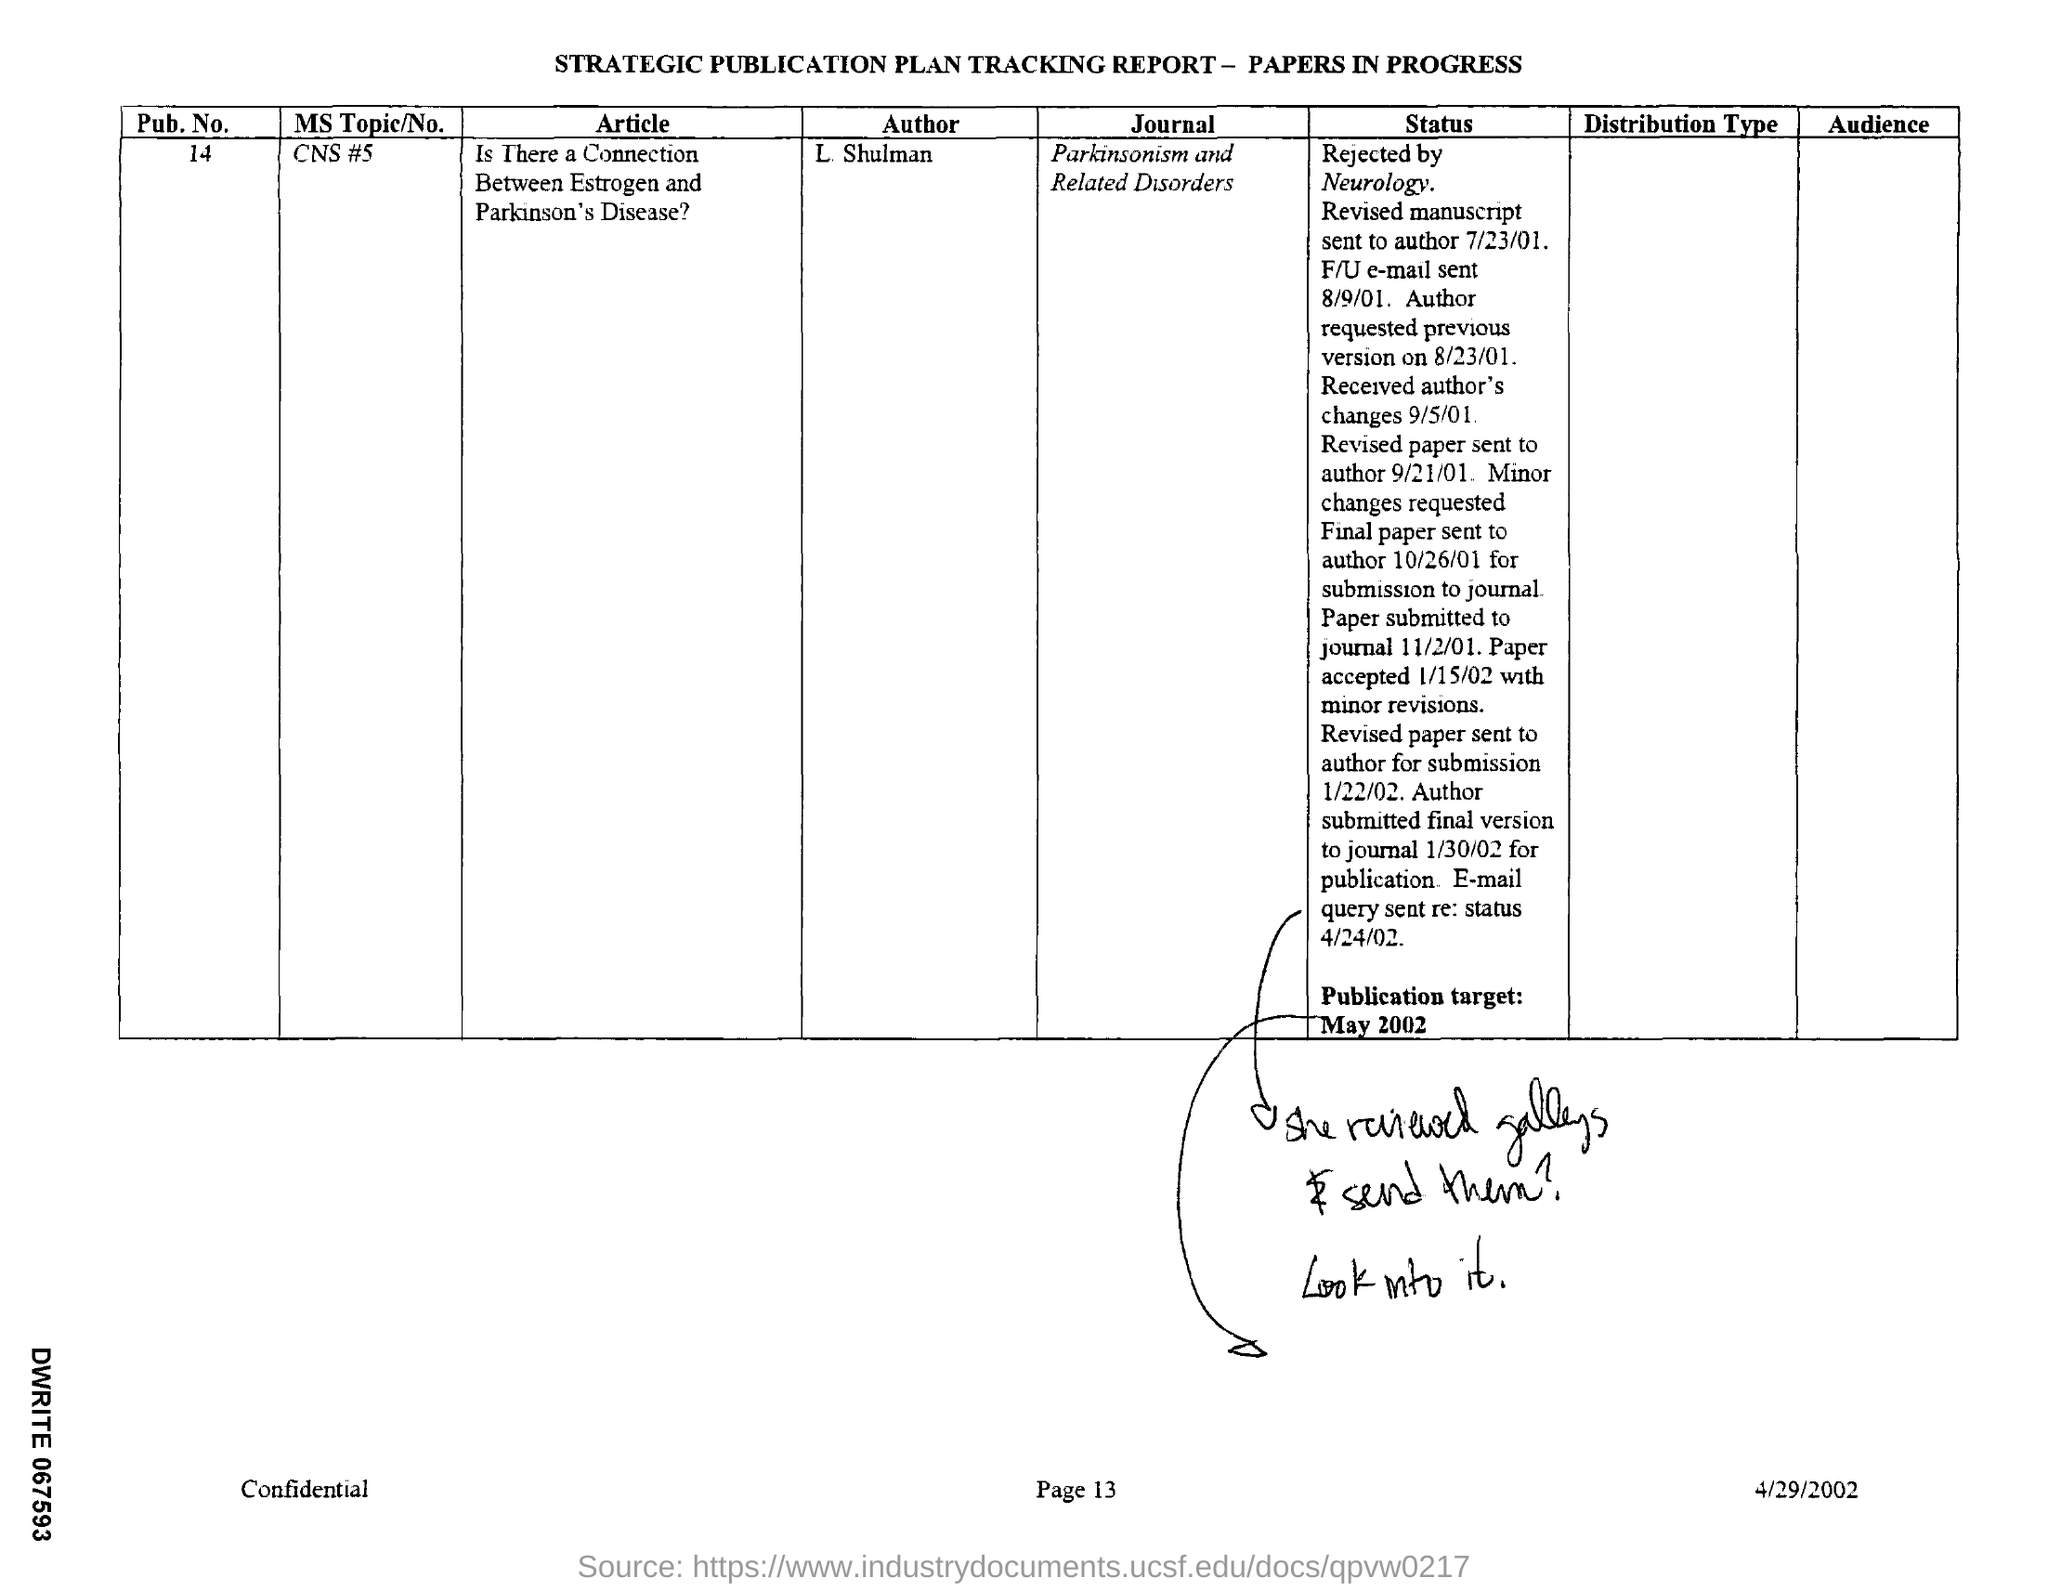Identify some key points in this picture. The MS topic/no. is CNS #5. The article in question is titled "What is the name of the article? Is There a Connection Between Estrogen and Parkinson's Disease?... The document was dated on April 29, 2002. This document is a strategic publication plan tracking report for papers in progress. What is the publication number? 